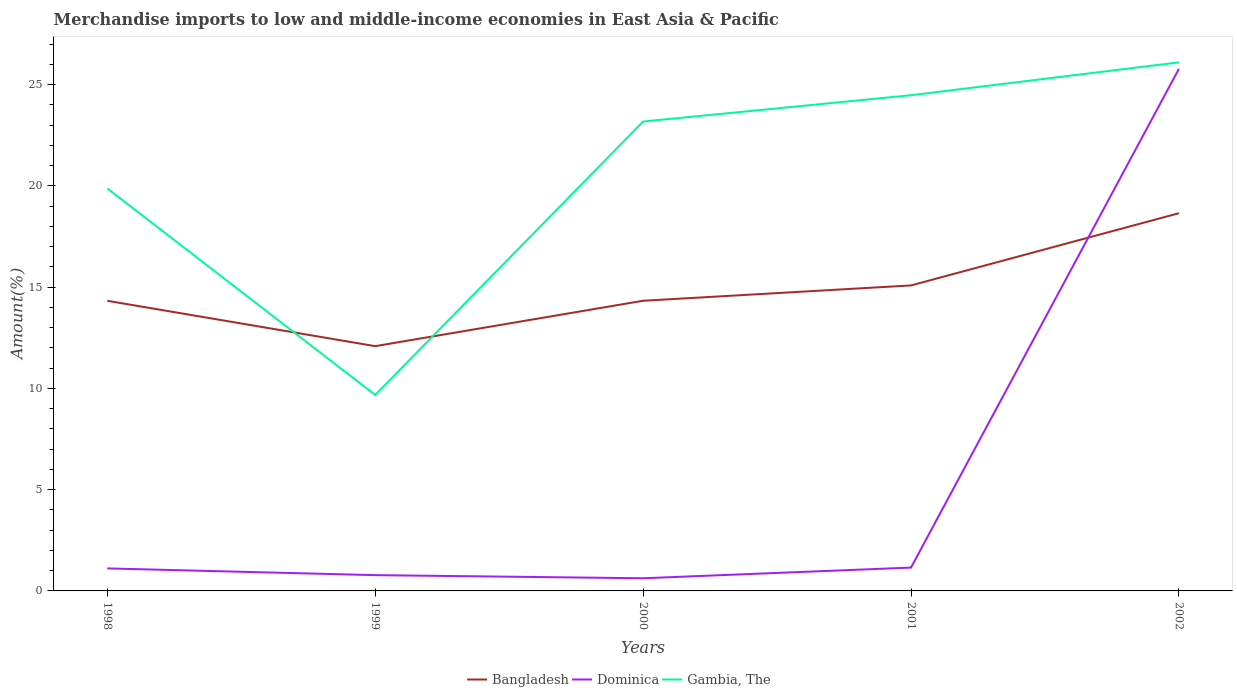How many different coloured lines are there?
Make the answer very short. 3. Does the line corresponding to Bangladesh intersect with the line corresponding to Dominica?
Offer a very short reply. Yes. Across all years, what is the maximum percentage of amount earned from merchandise imports in Dominica?
Offer a terse response. 0.62. In which year was the percentage of amount earned from merchandise imports in Dominica maximum?
Your answer should be compact. 2000. What is the total percentage of amount earned from merchandise imports in Gambia, The in the graph?
Give a very brief answer. -13.5. What is the difference between the highest and the second highest percentage of amount earned from merchandise imports in Gambia, The?
Offer a very short reply. 16.42. What is the difference between the highest and the lowest percentage of amount earned from merchandise imports in Gambia, The?
Your answer should be compact. 3. How many years are there in the graph?
Offer a terse response. 5. Where does the legend appear in the graph?
Provide a succinct answer. Bottom center. How are the legend labels stacked?
Provide a succinct answer. Horizontal. What is the title of the graph?
Your answer should be compact. Merchandise imports to low and middle-income economies in East Asia & Pacific. What is the label or title of the X-axis?
Your answer should be compact. Years. What is the label or title of the Y-axis?
Your response must be concise. Amount(%). What is the Amount(%) in Bangladesh in 1998?
Your answer should be compact. 14.33. What is the Amount(%) of Dominica in 1998?
Your answer should be compact. 1.11. What is the Amount(%) of Gambia, The in 1998?
Provide a short and direct response. 19.88. What is the Amount(%) of Bangladesh in 1999?
Offer a very short reply. 12.09. What is the Amount(%) in Dominica in 1999?
Keep it short and to the point. 0.78. What is the Amount(%) in Gambia, The in 1999?
Offer a very short reply. 9.68. What is the Amount(%) in Bangladesh in 2000?
Provide a succinct answer. 14.33. What is the Amount(%) in Dominica in 2000?
Provide a succinct answer. 0.62. What is the Amount(%) in Gambia, The in 2000?
Give a very brief answer. 23.18. What is the Amount(%) in Bangladesh in 2001?
Offer a very short reply. 15.09. What is the Amount(%) of Dominica in 2001?
Your answer should be very brief. 1.15. What is the Amount(%) of Gambia, The in 2001?
Offer a very short reply. 24.48. What is the Amount(%) in Bangladesh in 2002?
Provide a short and direct response. 18.65. What is the Amount(%) of Dominica in 2002?
Give a very brief answer. 25.78. What is the Amount(%) in Gambia, The in 2002?
Offer a terse response. 26.1. Across all years, what is the maximum Amount(%) in Bangladesh?
Make the answer very short. 18.65. Across all years, what is the maximum Amount(%) of Dominica?
Your answer should be compact. 25.78. Across all years, what is the maximum Amount(%) of Gambia, The?
Provide a succinct answer. 26.1. Across all years, what is the minimum Amount(%) in Bangladesh?
Ensure brevity in your answer.  12.09. Across all years, what is the minimum Amount(%) of Dominica?
Offer a terse response. 0.62. Across all years, what is the minimum Amount(%) in Gambia, The?
Provide a succinct answer. 9.68. What is the total Amount(%) in Bangladesh in the graph?
Make the answer very short. 74.48. What is the total Amount(%) of Dominica in the graph?
Your answer should be compact. 29.45. What is the total Amount(%) in Gambia, The in the graph?
Your answer should be very brief. 103.32. What is the difference between the Amount(%) of Bangladesh in 1998 and that in 1999?
Keep it short and to the point. 2.24. What is the difference between the Amount(%) in Dominica in 1998 and that in 1999?
Ensure brevity in your answer.  0.33. What is the difference between the Amount(%) of Gambia, The in 1998 and that in 1999?
Provide a short and direct response. 10.2. What is the difference between the Amount(%) in Bangladesh in 1998 and that in 2000?
Your answer should be compact. -0. What is the difference between the Amount(%) of Dominica in 1998 and that in 2000?
Offer a very short reply. 0.49. What is the difference between the Amount(%) of Gambia, The in 1998 and that in 2000?
Give a very brief answer. -3.3. What is the difference between the Amount(%) of Bangladesh in 1998 and that in 2001?
Offer a terse response. -0.76. What is the difference between the Amount(%) of Dominica in 1998 and that in 2001?
Your response must be concise. -0.04. What is the difference between the Amount(%) of Gambia, The in 1998 and that in 2001?
Give a very brief answer. -4.6. What is the difference between the Amount(%) of Bangladesh in 1998 and that in 2002?
Give a very brief answer. -4.33. What is the difference between the Amount(%) in Dominica in 1998 and that in 2002?
Give a very brief answer. -24.67. What is the difference between the Amount(%) in Gambia, The in 1998 and that in 2002?
Your answer should be very brief. -6.22. What is the difference between the Amount(%) in Bangladesh in 1999 and that in 2000?
Provide a succinct answer. -2.24. What is the difference between the Amount(%) in Dominica in 1999 and that in 2000?
Provide a short and direct response. 0.15. What is the difference between the Amount(%) of Gambia, The in 1999 and that in 2000?
Offer a very short reply. -13.5. What is the difference between the Amount(%) in Bangladesh in 1999 and that in 2001?
Give a very brief answer. -3. What is the difference between the Amount(%) in Dominica in 1999 and that in 2001?
Your answer should be compact. -0.37. What is the difference between the Amount(%) in Gambia, The in 1999 and that in 2001?
Offer a terse response. -14.8. What is the difference between the Amount(%) in Bangladesh in 1999 and that in 2002?
Provide a succinct answer. -6.57. What is the difference between the Amount(%) in Dominica in 1999 and that in 2002?
Give a very brief answer. -25. What is the difference between the Amount(%) of Gambia, The in 1999 and that in 2002?
Keep it short and to the point. -16.42. What is the difference between the Amount(%) of Bangladesh in 2000 and that in 2001?
Provide a short and direct response. -0.76. What is the difference between the Amount(%) of Dominica in 2000 and that in 2001?
Your answer should be compact. -0.53. What is the difference between the Amount(%) in Gambia, The in 2000 and that in 2001?
Your answer should be very brief. -1.3. What is the difference between the Amount(%) in Bangladesh in 2000 and that in 2002?
Your response must be concise. -4.32. What is the difference between the Amount(%) in Dominica in 2000 and that in 2002?
Make the answer very short. -25.16. What is the difference between the Amount(%) of Gambia, The in 2000 and that in 2002?
Provide a succinct answer. -2.92. What is the difference between the Amount(%) in Bangladesh in 2001 and that in 2002?
Provide a succinct answer. -3.57. What is the difference between the Amount(%) of Dominica in 2001 and that in 2002?
Keep it short and to the point. -24.63. What is the difference between the Amount(%) in Gambia, The in 2001 and that in 2002?
Your response must be concise. -1.62. What is the difference between the Amount(%) of Bangladesh in 1998 and the Amount(%) of Dominica in 1999?
Make the answer very short. 13.55. What is the difference between the Amount(%) of Bangladesh in 1998 and the Amount(%) of Gambia, The in 1999?
Give a very brief answer. 4.65. What is the difference between the Amount(%) of Dominica in 1998 and the Amount(%) of Gambia, The in 1999?
Make the answer very short. -8.57. What is the difference between the Amount(%) of Bangladesh in 1998 and the Amount(%) of Dominica in 2000?
Make the answer very short. 13.7. What is the difference between the Amount(%) in Bangladesh in 1998 and the Amount(%) in Gambia, The in 2000?
Provide a short and direct response. -8.85. What is the difference between the Amount(%) in Dominica in 1998 and the Amount(%) in Gambia, The in 2000?
Your response must be concise. -22.07. What is the difference between the Amount(%) of Bangladesh in 1998 and the Amount(%) of Dominica in 2001?
Keep it short and to the point. 13.18. What is the difference between the Amount(%) of Bangladesh in 1998 and the Amount(%) of Gambia, The in 2001?
Ensure brevity in your answer.  -10.15. What is the difference between the Amount(%) in Dominica in 1998 and the Amount(%) in Gambia, The in 2001?
Make the answer very short. -23.37. What is the difference between the Amount(%) in Bangladesh in 1998 and the Amount(%) in Dominica in 2002?
Offer a very short reply. -11.45. What is the difference between the Amount(%) in Bangladesh in 1998 and the Amount(%) in Gambia, The in 2002?
Offer a terse response. -11.77. What is the difference between the Amount(%) of Dominica in 1998 and the Amount(%) of Gambia, The in 2002?
Provide a succinct answer. -24.99. What is the difference between the Amount(%) in Bangladesh in 1999 and the Amount(%) in Dominica in 2000?
Make the answer very short. 11.46. What is the difference between the Amount(%) in Bangladesh in 1999 and the Amount(%) in Gambia, The in 2000?
Ensure brevity in your answer.  -11.09. What is the difference between the Amount(%) of Dominica in 1999 and the Amount(%) of Gambia, The in 2000?
Keep it short and to the point. -22.4. What is the difference between the Amount(%) of Bangladesh in 1999 and the Amount(%) of Dominica in 2001?
Your response must be concise. 10.93. What is the difference between the Amount(%) of Bangladesh in 1999 and the Amount(%) of Gambia, The in 2001?
Your response must be concise. -12.39. What is the difference between the Amount(%) of Dominica in 1999 and the Amount(%) of Gambia, The in 2001?
Your answer should be very brief. -23.7. What is the difference between the Amount(%) of Bangladesh in 1999 and the Amount(%) of Dominica in 2002?
Your answer should be very brief. -13.69. What is the difference between the Amount(%) in Bangladesh in 1999 and the Amount(%) in Gambia, The in 2002?
Your response must be concise. -14.01. What is the difference between the Amount(%) of Dominica in 1999 and the Amount(%) of Gambia, The in 2002?
Your response must be concise. -25.32. What is the difference between the Amount(%) of Bangladesh in 2000 and the Amount(%) of Dominica in 2001?
Provide a short and direct response. 13.18. What is the difference between the Amount(%) of Bangladesh in 2000 and the Amount(%) of Gambia, The in 2001?
Make the answer very short. -10.15. What is the difference between the Amount(%) of Dominica in 2000 and the Amount(%) of Gambia, The in 2001?
Give a very brief answer. -23.85. What is the difference between the Amount(%) of Bangladesh in 2000 and the Amount(%) of Dominica in 2002?
Offer a terse response. -11.45. What is the difference between the Amount(%) in Bangladesh in 2000 and the Amount(%) in Gambia, The in 2002?
Give a very brief answer. -11.77. What is the difference between the Amount(%) in Dominica in 2000 and the Amount(%) in Gambia, The in 2002?
Your answer should be very brief. -25.48. What is the difference between the Amount(%) of Bangladesh in 2001 and the Amount(%) of Dominica in 2002?
Offer a very short reply. -10.7. What is the difference between the Amount(%) of Bangladesh in 2001 and the Amount(%) of Gambia, The in 2002?
Give a very brief answer. -11.02. What is the difference between the Amount(%) of Dominica in 2001 and the Amount(%) of Gambia, The in 2002?
Ensure brevity in your answer.  -24.95. What is the average Amount(%) in Bangladesh per year?
Make the answer very short. 14.9. What is the average Amount(%) in Dominica per year?
Keep it short and to the point. 5.89. What is the average Amount(%) of Gambia, The per year?
Provide a short and direct response. 20.66. In the year 1998, what is the difference between the Amount(%) of Bangladesh and Amount(%) of Dominica?
Give a very brief answer. 13.22. In the year 1998, what is the difference between the Amount(%) in Bangladesh and Amount(%) in Gambia, The?
Ensure brevity in your answer.  -5.55. In the year 1998, what is the difference between the Amount(%) in Dominica and Amount(%) in Gambia, The?
Give a very brief answer. -18.77. In the year 1999, what is the difference between the Amount(%) in Bangladesh and Amount(%) in Dominica?
Offer a very short reply. 11.31. In the year 1999, what is the difference between the Amount(%) of Bangladesh and Amount(%) of Gambia, The?
Your response must be concise. 2.41. In the year 1999, what is the difference between the Amount(%) in Dominica and Amount(%) in Gambia, The?
Offer a terse response. -8.9. In the year 2000, what is the difference between the Amount(%) in Bangladesh and Amount(%) in Dominica?
Keep it short and to the point. 13.7. In the year 2000, what is the difference between the Amount(%) in Bangladesh and Amount(%) in Gambia, The?
Make the answer very short. -8.85. In the year 2000, what is the difference between the Amount(%) in Dominica and Amount(%) in Gambia, The?
Your response must be concise. -22.56. In the year 2001, what is the difference between the Amount(%) in Bangladesh and Amount(%) in Dominica?
Make the answer very short. 13.93. In the year 2001, what is the difference between the Amount(%) in Bangladesh and Amount(%) in Gambia, The?
Your answer should be very brief. -9.39. In the year 2001, what is the difference between the Amount(%) of Dominica and Amount(%) of Gambia, The?
Give a very brief answer. -23.33. In the year 2002, what is the difference between the Amount(%) of Bangladesh and Amount(%) of Dominica?
Offer a terse response. -7.13. In the year 2002, what is the difference between the Amount(%) of Bangladesh and Amount(%) of Gambia, The?
Keep it short and to the point. -7.45. In the year 2002, what is the difference between the Amount(%) in Dominica and Amount(%) in Gambia, The?
Ensure brevity in your answer.  -0.32. What is the ratio of the Amount(%) of Bangladesh in 1998 to that in 1999?
Offer a very short reply. 1.19. What is the ratio of the Amount(%) in Dominica in 1998 to that in 1999?
Offer a very short reply. 1.43. What is the ratio of the Amount(%) of Gambia, The in 1998 to that in 1999?
Give a very brief answer. 2.05. What is the ratio of the Amount(%) in Bangladesh in 1998 to that in 2000?
Your response must be concise. 1. What is the ratio of the Amount(%) of Dominica in 1998 to that in 2000?
Provide a succinct answer. 1.78. What is the ratio of the Amount(%) in Gambia, The in 1998 to that in 2000?
Your response must be concise. 0.86. What is the ratio of the Amount(%) of Bangladesh in 1998 to that in 2001?
Ensure brevity in your answer.  0.95. What is the ratio of the Amount(%) in Dominica in 1998 to that in 2001?
Offer a terse response. 0.96. What is the ratio of the Amount(%) of Gambia, The in 1998 to that in 2001?
Offer a terse response. 0.81. What is the ratio of the Amount(%) in Bangladesh in 1998 to that in 2002?
Keep it short and to the point. 0.77. What is the ratio of the Amount(%) of Dominica in 1998 to that in 2002?
Your answer should be very brief. 0.04. What is the ratio of the Amount(%) in Gambia, The in 1998 to that in 2002?
Provide a succinct answer. 0.76. What is the ratio of the Amount(%) in Bangladesh in 1999 to that in 2000?
Your response must be concise. 0.84. What is the ratio of the Amount(%) of Dominica in 1999 to that in 2000?
Keep it short and to the point. 1.25. What is the ratio of the Amount(%) of Gambia, The in 1999 to that in 2000?
Offer a very short reply. 0.42. What is the ratio of the Amount(%) of Bangladesh in 1999 to that in 2001?
Your response must be concise. 0.8. What is the ratio of the Amount(%) in Dominica in 1999 to that in 2001?
Ensure brevity in your answer.  0.68. What is the ratio of the Amount(%) of Gambia, The in 1999 to that in 2001?
Provide a succinct answer. 0.4. What is the ratio of the Amount(%) of Bangladesh in 1999 to that in 2002?
Provide a succinct answer. 0.65. What is the ratio of the Amount(%) in Dominica in 1999 to that in 2002?
Ensure brevity in your answer.  0.03. What is the ratio of the Amount(%) in Gambia, The in 1999 to that in 2002?
Keep it short and to the point. 0.37. What is the ratio of the Amount(%) of Bangladesh in 2000 to that in 2001?
Offer a very short reply. 0.95. What is the ratio of the Amount(%) of Dominica in 2000 to that in 2001?
Give a very brief answer. 0.54. What is the ratio of the Amount(%) of Gambia, The in 2000 to that in 2001?
Provide a succinct answer. 0.95. What is the ratio of the Amount(%) of Bangladesh in 2000 to that in 2002?
Offer a terse response. 0.77. What is the ratio of the Amount(%) in Dominica in 2000 to that in 2002?
Give a very brief answer. 0.02. What is the ratio of the Amount(%) in Gambia, The in 2000 to that in 2002?
Provide a short and direct response. 0.89. What is the ratio of the Amount(%) in Bangladesh in 2001 to that in 2002?
Keep it short and to the point. 0.81. What is the ratio of the Amount(%) of Dominica in 2001 to that in 2002?
Offer a very short reply. 0.04. What is the ratio of the Amount(%) in Gambia, The in 2001 to that in 2002?
Provide a succinct answer. 0.94. What is the difference between the highest and the second highest Amount(%) in Bangladesh?
Offer a terse response. 3.57. What is the difference between the highest and the second highest Amount(%) in Dominica?
Keep it short and to the point. 24.63. What is the difference between the highest and the second highest Amount(%) of Gambia, The?
Make the answer very short. 1.62. What is the difference between the highest and the lowest Amount(%) of Bangladesh?
Give a very brief answer. 6.57. What is the difference between the highest and the lowest Amount(%) of Dominica?
Keep it short and to the point. 25.16. What is the difference between the highest and the lowest Amount(%) of Gambia, The?
Your answer should be very brief. 16.42. 